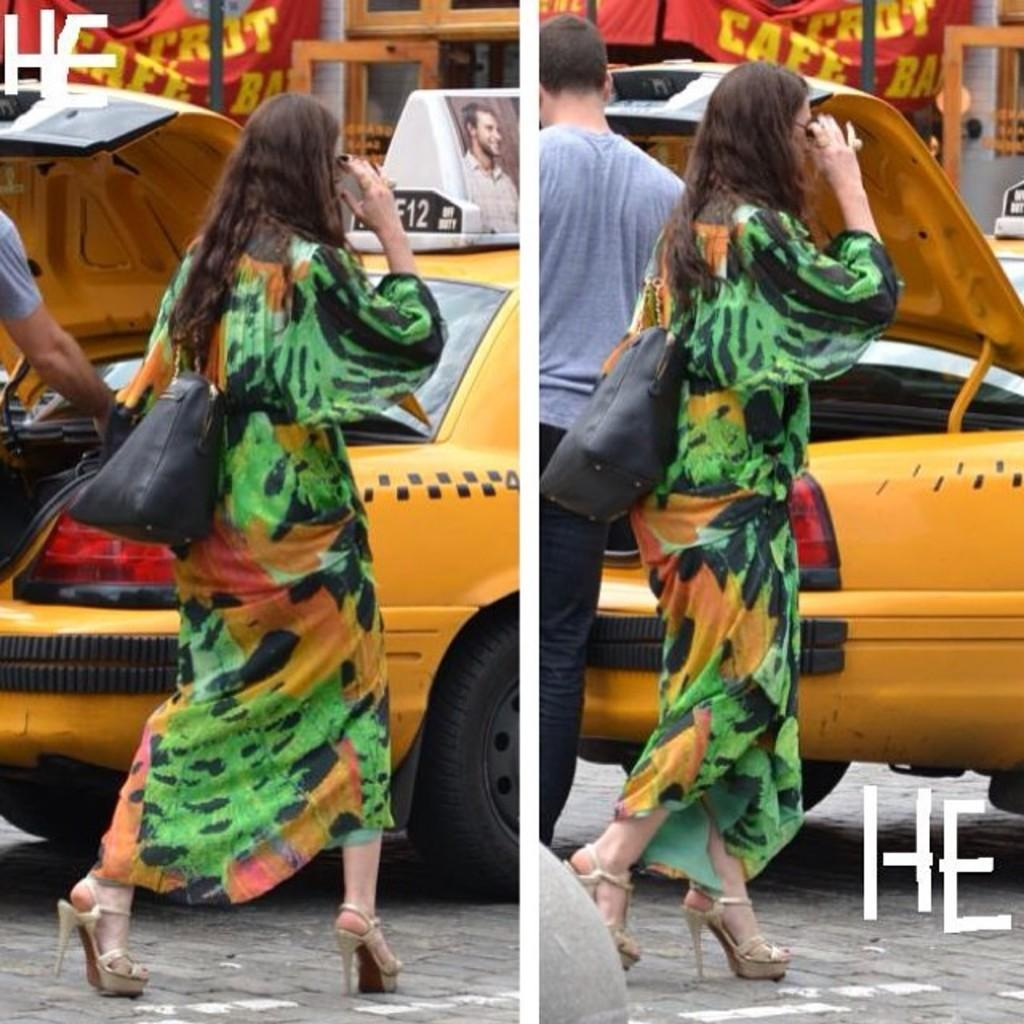Provide a one-sentence caption for the provided image. A woman in a green dress walks down a street and letter H an E are in the lower right and upper left corner. 